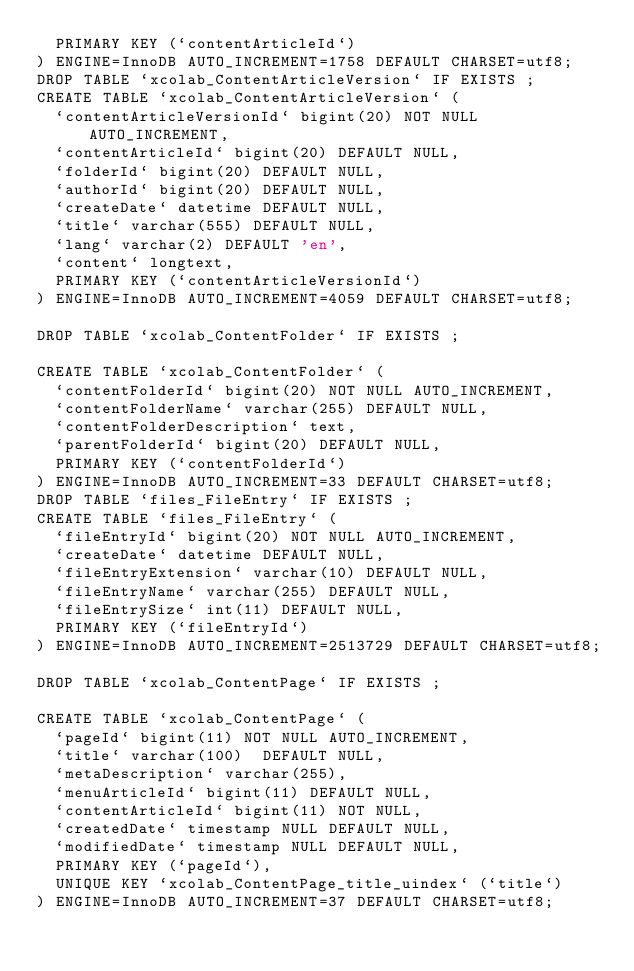Convert code to text. <code><loc_0><loc_0><loc_500><loc_500><_SQL_>  PRIMARY KEY (`contentArticleId`)
) ENGINE=InnoDB AUTO_INCREMENT=1758 DEFAULT CHARSET=utf8;
DROP TABLE `xcolab_ContentArticleVersion` IF EXISTS ;
CREATE TABLE `xcolab_ContentArticleVersion` (
  `contentArticleVersionId` bigint(20) NOT NULL AUTO_INCREMENT,
  `contentArticleId` bigint(20) DEFAULT NULL,
  `folderId` bigint(20) DEFAULT NULL,
  `authorId` bigint(20) DEFAULT NULL,
  `createDate` datetime DEFAULT NULL,
  `title` varchar(555) DEFAULT NULL,
  `lang` varchar(2) DEFAULT 'en',
  `content` longtext,
  PRIMARY KEY (`contentArticleVersionId`)
) ENGINE=InnoDB AUTO_INCREMENT=4059 DEFAULT CHARSET=utf8;

DROP TABLE `xcolab_ContentFolder` IF EXISTS ;

CREATE TABLE `xcolab_ContentFolder` (
  `contentFolderId` bigint(20) NOT NULL AUTO_INCREMENT,
  `contentFolderName` varchar(255) DEFAULT NULL,
  `contentFolderDescription` text,
  `parentFolderId` bigint(20) DEFAULT NULL,
  PRIMARY KEY (`contentFolderId`)
) ENGINE=InnoDB AUTO_INCREMENT=33 DEFAULT CHARSET=utf8;
DROP TABLE `files_FileEntry` IF EXISTS ;
CREATE TABLE `files_FileEntry` (
  `fileEntryId` bigint(20) NOT NULL AUTO_INCREMENT,
  `createDate` datetime DEFAULT NULL,
  `fileEntryExtension` varchar(10) DEFAULT NULL,
  `fileEntryName` varchar(255) DEFAULT NULL,
  `fileEntrySize` int(11) DEFAULT NULL,
  PRIMARY KEY (`fileEntryId`)
) ENGINE=InnoDB AUTO_INCREMENT=2513729 DEFAULT CHARSET=utf8;

DROP TABLE `xcolab_ContentPage` IF EXISTS ;

CREATE TABLE `xcolab_ContentPage` (
  `pageId` bigint(11) NOT NULL AUTO_INCREMENT,
  `title` varchar(100)  DEFAULT NULL,
  `metaDescription` varchar(255),
  `menuArticleId` bigint(11) DEFAULT NULL,
  `contentArticleId` bigint(11) NOT NULL,
  `createdDate` timestamp NULL DEFAULT NULL,
  `modifiedDate` timestamp NULL DEFAULT NULL,
  PRIMARY KEY (`pageId`),
  UNIQUE KEY `xcolab_ContentPage_title_uindex` (`title`)
) ENGINE=InnoDB AUTO_INCREMENT=37 DEFAULT CHARSET=utf8;
</code> 